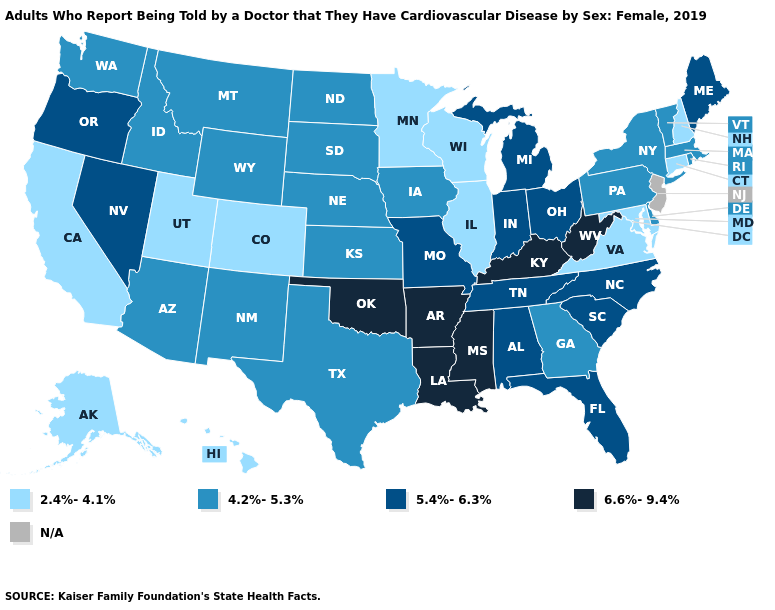Does Oregon have the highest value in the USA?
Quick response, please. No. What is the value of Kentucky?
Write a very short answer. 6.6%-9.4%. What is the value of Utah?
Give a very brief answer. 2.4%-4.1%. Among the states that border Tennessee , does Virginia have the lowest value?
Give a very brief answer. Yes. What is the value of Ohio?
Give a very brief answer. 5.4%-6.3%. Among the states that border Minnesota , does South Dakota have the highest value?
Short answer required. Yes. What is the value of Vermont?
Concise answer only. 4.2%-5.3%. Name the states that have a value in the range 4.2%-5.3%?
Short answer required. Arizona, Delaware, Georgia, Idaho, Iowa, Kansas, Massachusetts, Montana, Nebraska, New Mexico, New York, North Dakota, Pennsylvania, Rhode Island, South Dakota, Texas, Vermont, Washington, Wyoming. Name the states that have a value in the range 4.2%-5.3%?
Short answer required. Arizona, Delaware, Georgia, Idaho, Iowa, Kansas, Massachusetts, Montana, Nebraska, New Mexico, New York, North Dakota, Pennsylvania, Rhode Island, South Dakota, Texas, Vermont, Washington, Wyoming. What is the lowest value in states that border Alabama?
Answer briefly. 4.2%-5.3%. Does Nebraska have the lowest value in the MidWest?
Concise answer only. No. Name the states that have a value in the range N/A?
Answer briefly. New Jersey. Among the states that border Washington , does Idaho have the highest value?
Quick response, please. No. What is the value of Illinois?
Be succinct. 2.4%-4.1%. 